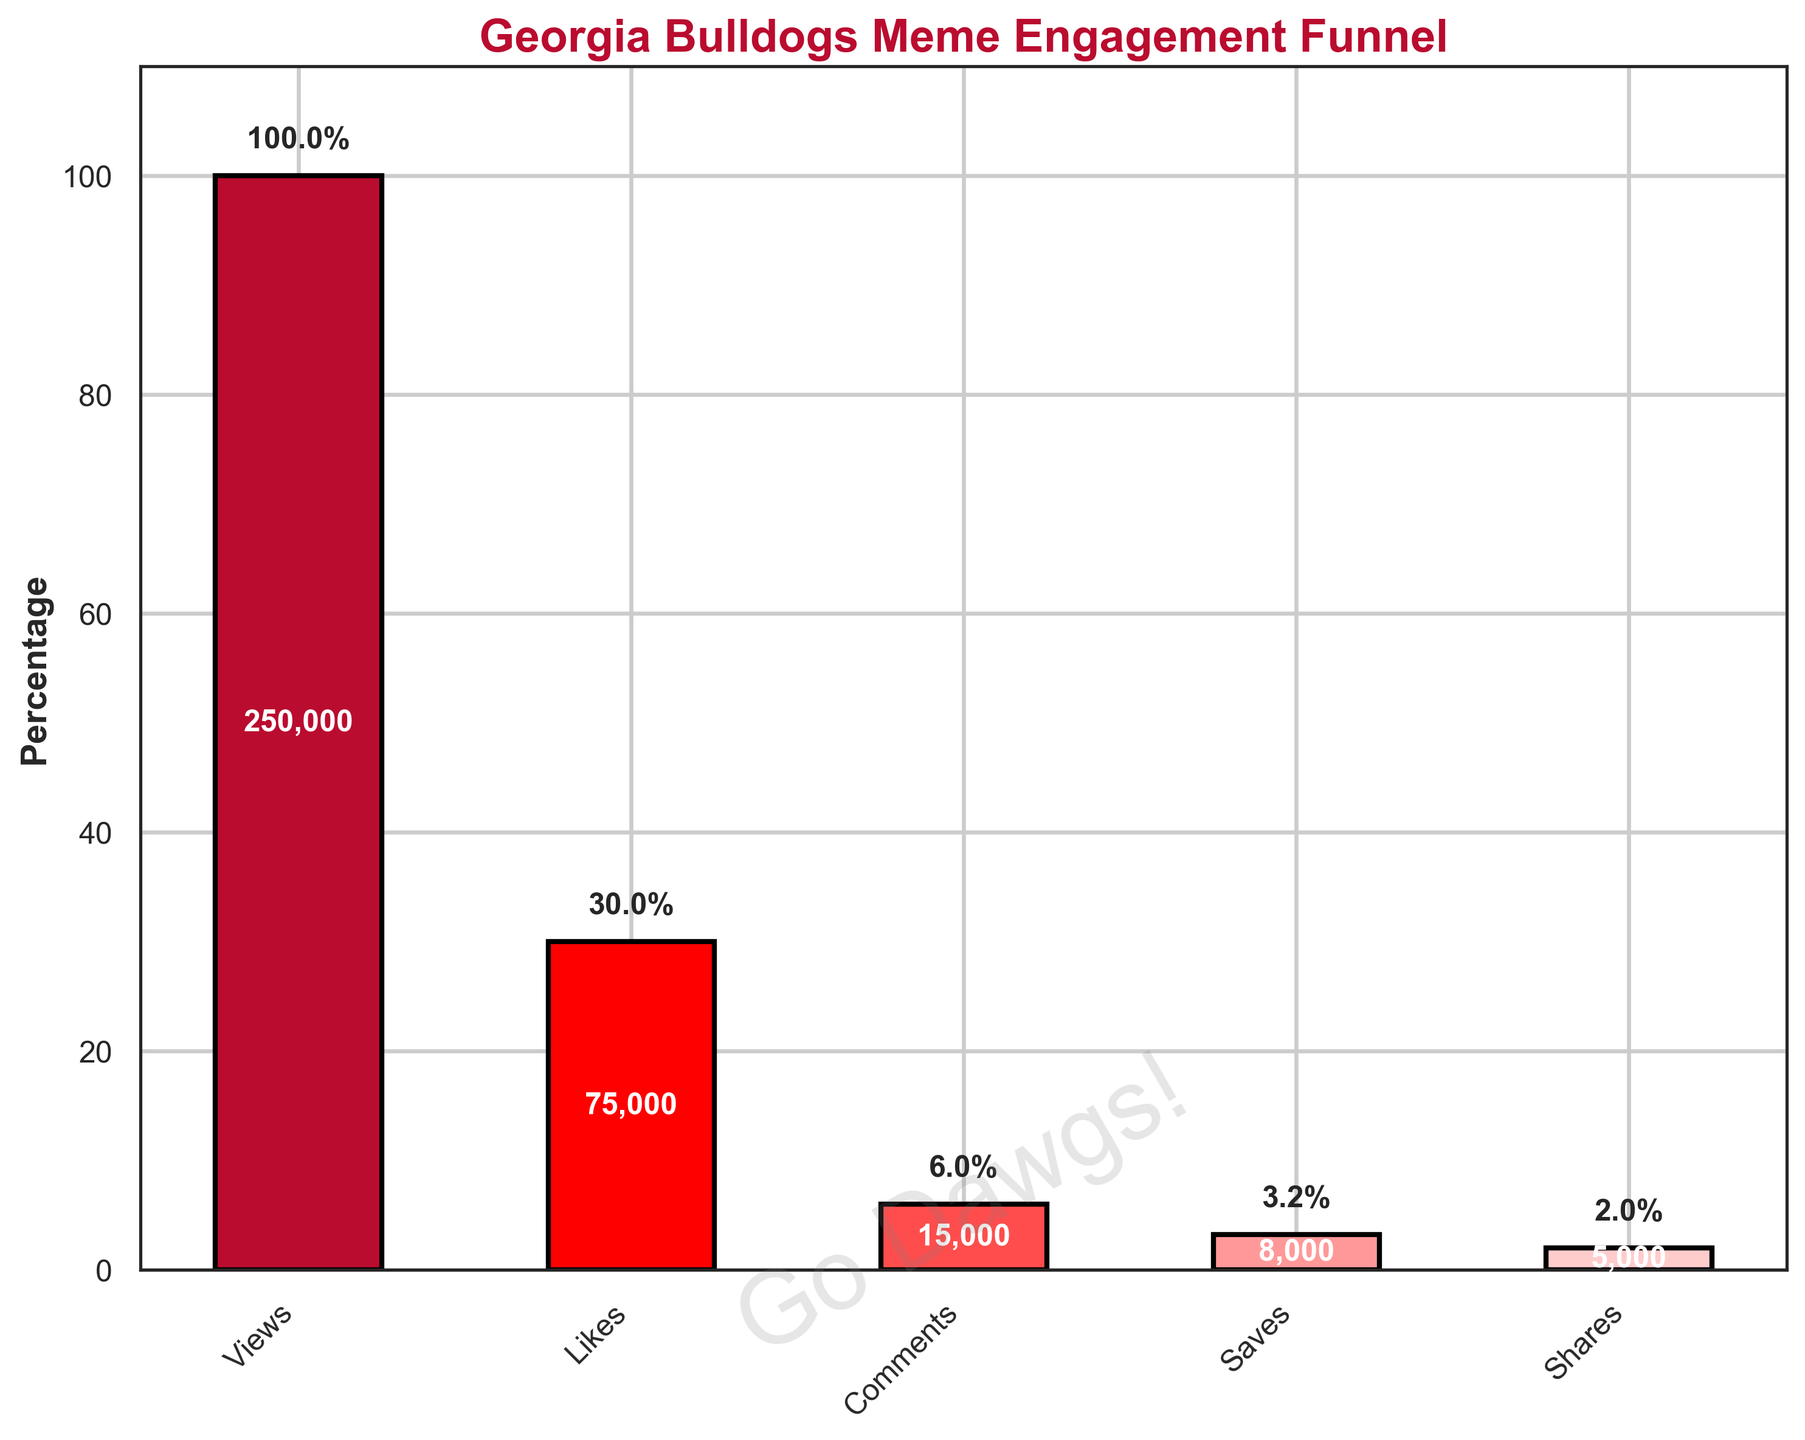How many stages are presented in the funnel? The plot visually depicts the engagement funnel, and you can count the number of distinct stages (bars) on the x-axis. Each stage has a label like "Views," "Likes," etc.
Answer: 5 What is the title of the plot? The title is displayed at the top of the plot, usually in a larger and bold font.
Answer: Georgia Bulldogs Meme Engagement Funnel What stage has the highest engagement count? The stage with the highest bar indicates the highest engagement count. We can see that the "Views" stage is the tallest bar.
Answer: Views Which stage has the lowest count? The stage with the lowest bar height represents the lowest count. In the funnel, "Shares" has the shortest bar.
Answer: Shares What percentage of views resulted in likes? To find this, note the percentage labels on the bars for "Views" and "Likes." The "Views" stage is at 100%, and the "Likes" stage shows 30%.
Answer: 30% How many comments were recorded? Read the count label within or on top of the "Comments" stage bar in the plot.
Answer: 15,000 Calculate the drop in count from Views to Shares. Subtract the "Shares" count from the "Views" count. The counts are 250,000 for Views and 5,000 for Shares, respectively.
Answer: 245,000 Which has a higher count: Saves or Comments? Compare the heights of the "Saves" and "Comments" bars. The "Comments" bar is higher.
Answer: Comments What's the sum of Likes and Saves? Add the counts for "Likes" and "Saves." They are 75,000 (Likes) and 8,000 (Saves).
Answer: 83,000 What is the percentage difference between Comments and Saves? Subtract the percentage of Saves from the percentage of Comments (6% and 3.2%, respectively, as visible on the graph).
Answer: 1.8% 